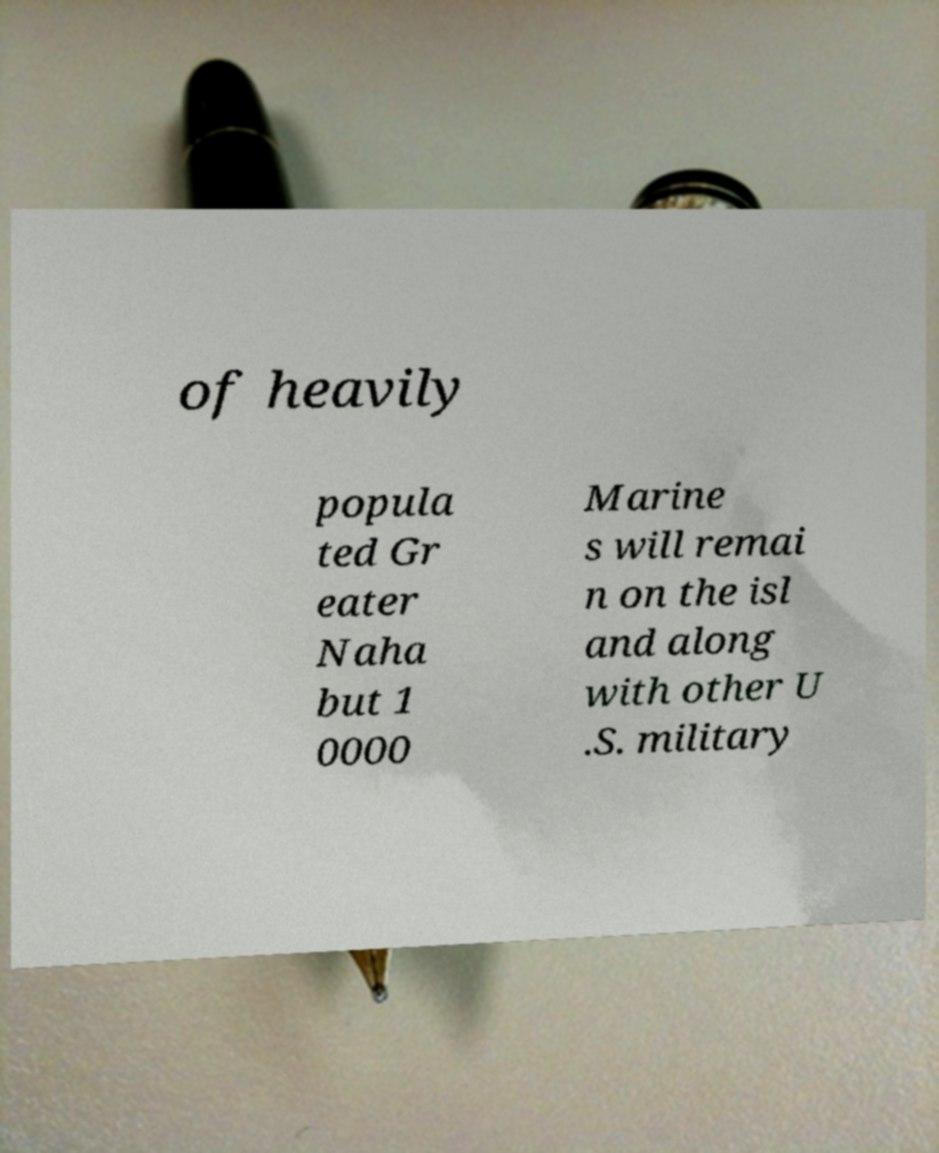Please read and relay the text visible in this image. What does it say? of heavily popula ted Gr eater Naha but 1 0000 Marine s will remai n on the isl and along with other U .S. military 